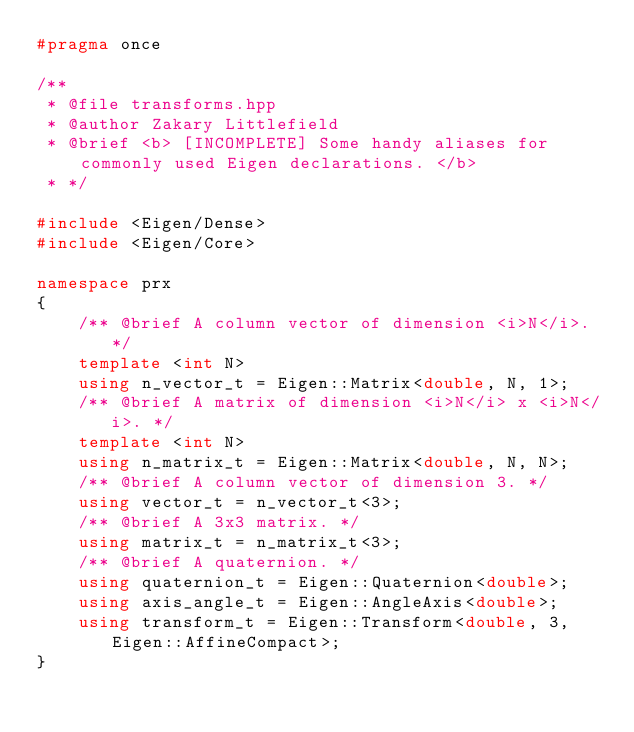<code> <loc_0><loc_0><loc_500><loc_500><_C++_>#pragma once

/**
 * @file transforms.hpp
 * @author Zakary Littlefield
 * @brief <b> [INCOMPLETE] Some handy aliases for commonly used Eigen declarations. </b>
 * */

#include <Eigen/Dense>
#include <Eigen/Core>

namespace prx
{
	/** @brief A column vector of dimension <i>N</i>. */
	template <int N>
	using n_vector_t = Eigen::Matrix<double, N, 1>;
	/** @brief A matrix of dimension <i>N</i> x <i>N</i>. */
	template <int N>
	using n_matrix_t = Eigen::Matrix<double, N, N>;
	/** @brief A column vector of dimension 3. */
	using vector_t = n_vector_t<3>;
	/** @brief A 3x3 matrix. */
	using matrix_t = n_matrix_t<3>;
	/** @brief A quaternion. */
	using quaternion_t = Eigen::Quaternion<double>;
	using axis_angle_t = Eigen::AngleAxis<double>;
	using transform_t = Eigen::Transform<double, 3, Eigen::AffineCompact>;
}</code> 